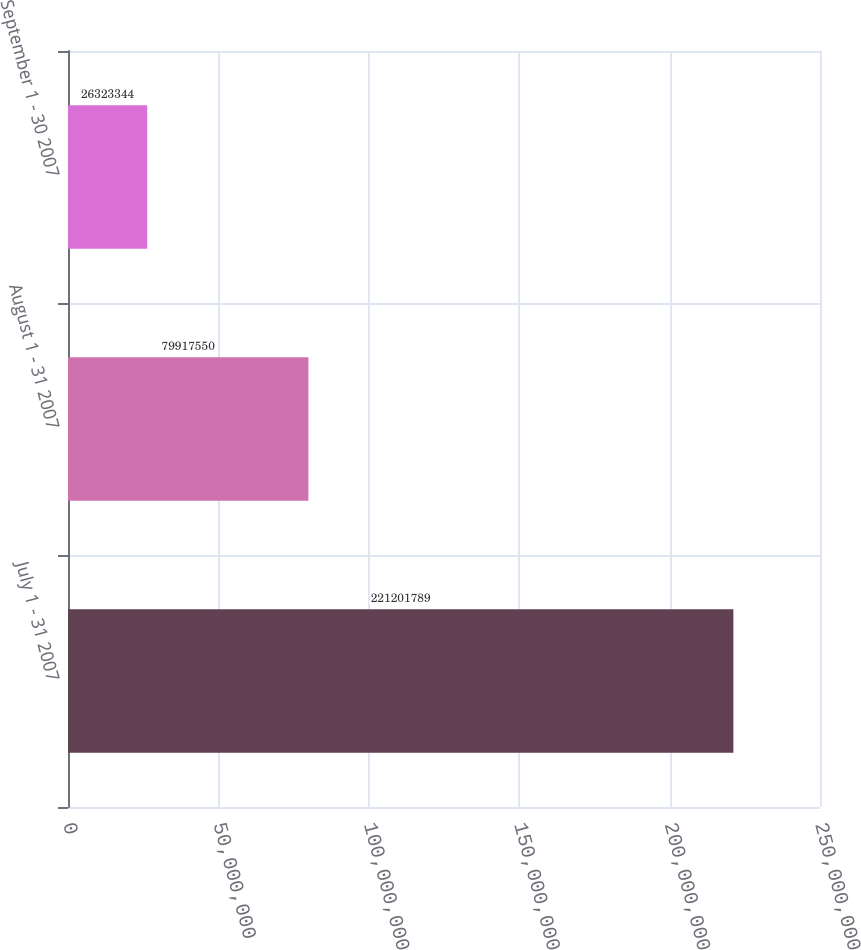Convert chart. <chart><loc_0><loc_0><loc_500><loc_500><bar_chart><fcel>July 1 - 31 2007<fcel>August 1 - 31 2007<fcel>September 1 - 30 2007<nl><fcel>2.21202e+08<fcel>7.99176e+07<fcel>2.63233e+07<nl></chart> 